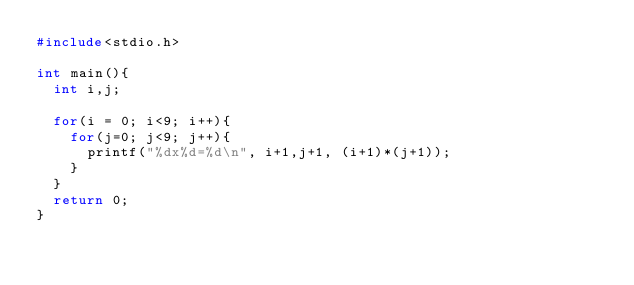<code> <loc_0><loc_0><loc_500><loc_500><_C_>#include<stdio.h>

int main(){
  int i,j;

  for(i = 0; i<9; i++){
    for(j=0; j<9; j++){
      printf("%dx%d=%d\n", i+1,j+1, (i+1)*(j+1));
    }
  }
  return 0;
}</code> 